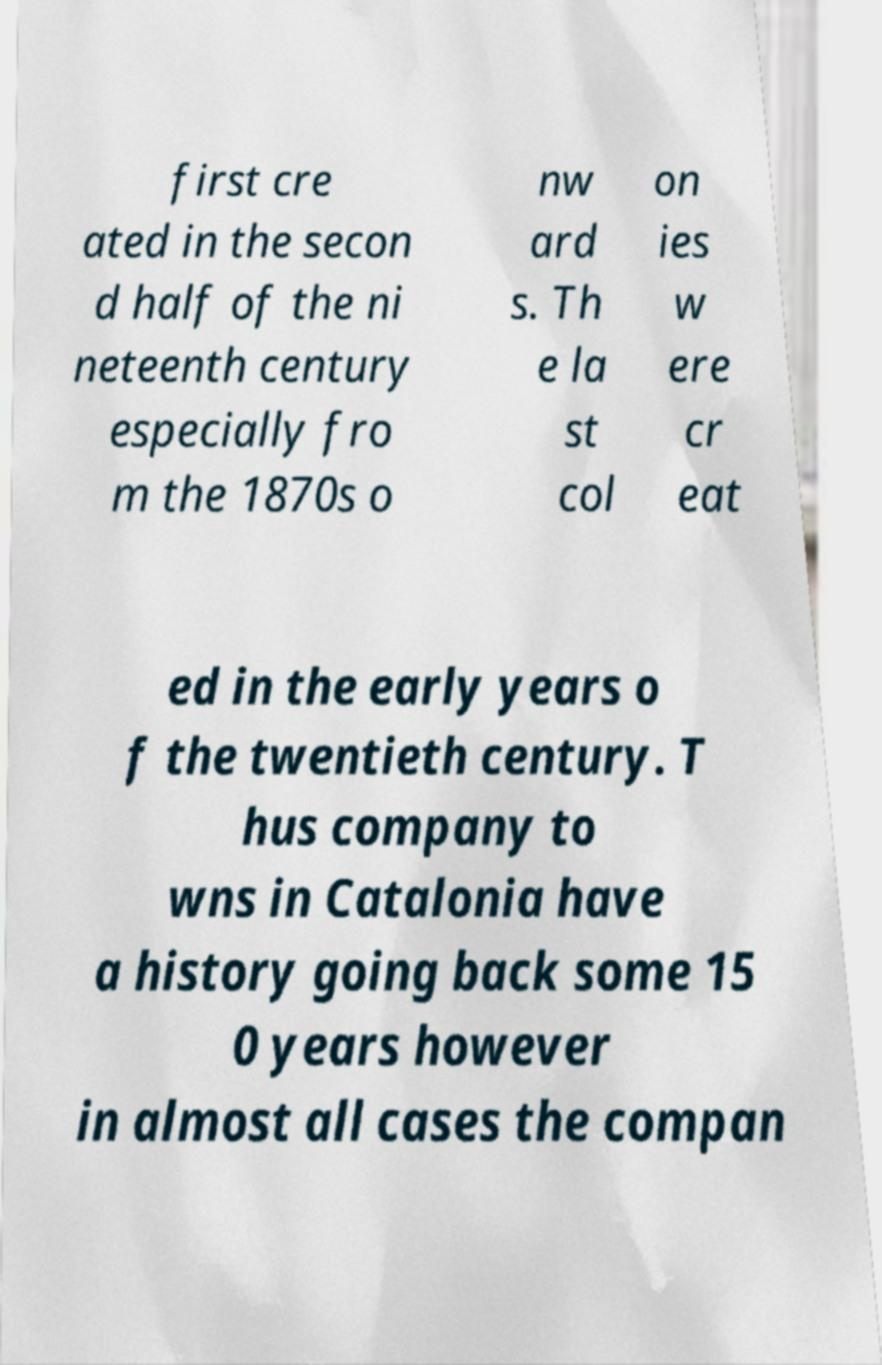For documentation purposes, I need the text within this image transcribed. Could you provide that? first cre ated in the secon d half of the ni neteenth century especially fro m the 1870s o nw ard s. Th e la st col on ies w ere cr eat ed in the early years o f the twentieth century. T hus company to wns in Catalonia have a history going back some 15 0 years however in almost all cases the compan 